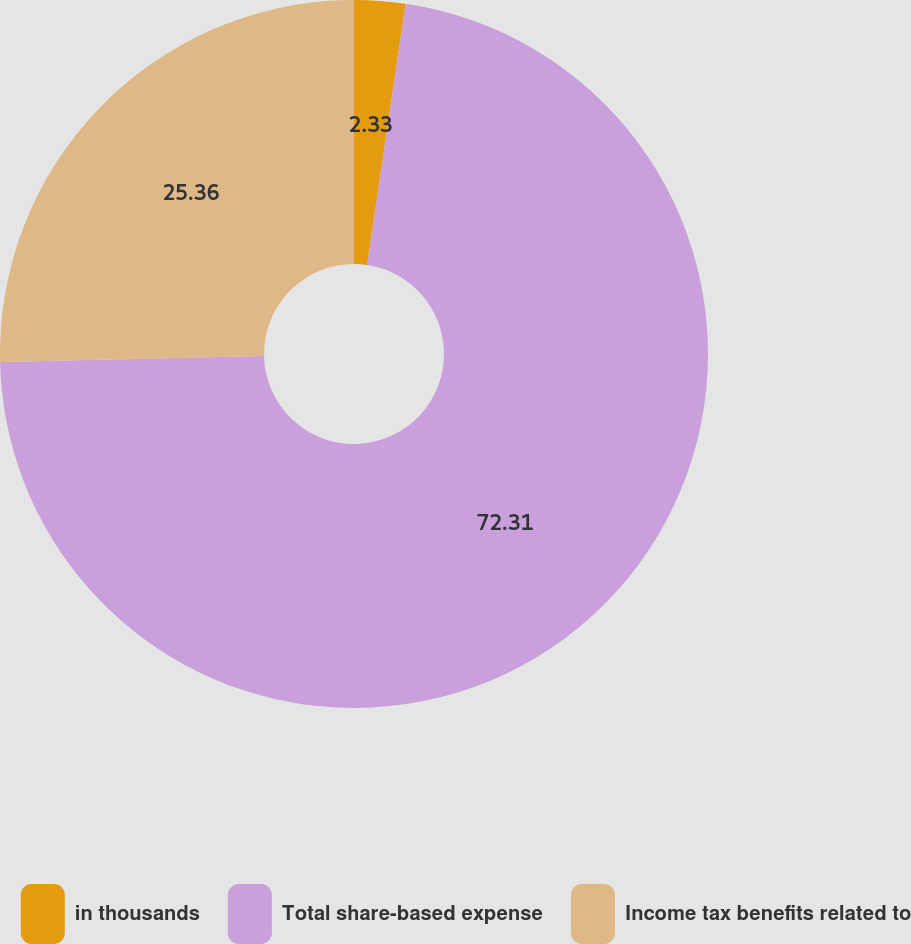Convert chart. <chart><loc_0><loc_0><loc_500><loc_500><pie_chart><fcel>in thousands<fcel>Total share-based expense<fcel>Income tax benefits related to<nl><fcel>2.33%<fcel>72.31%<fcel>25.36%<nl></chart> 